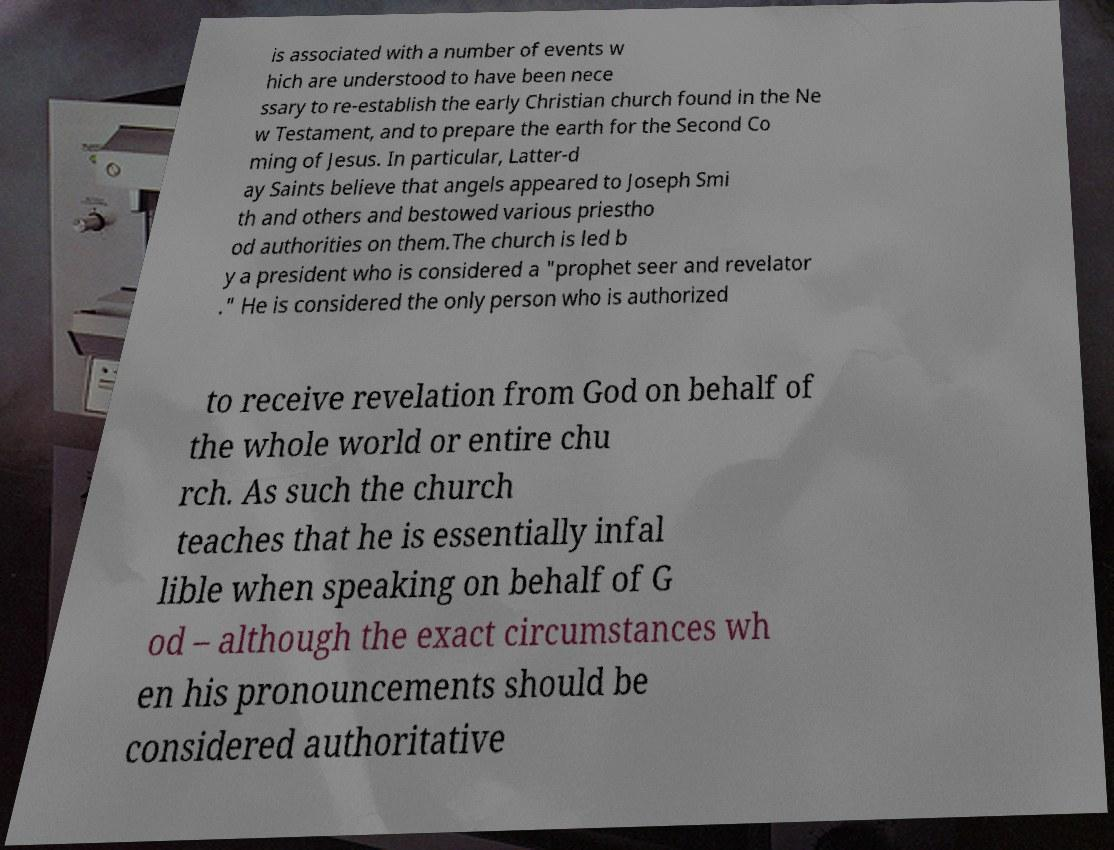For documentation purposes, I need the text within this image transcribed. Could you provide that? is associated with a number of events w hich are understood to have been nece ssary to re-establish the early Christian church found in the Ne w Testament, and to prepare the earth for the Second Co ming of Jesus. In particular, Latter-d ay Saints believe that angels appeared to Joseph Smi th and others and bestowed various priestho od authorities on them.The church is led b y a president who is considered a "prophet seer and revelator ." He is considered the only person who is authorized to receive revelation from God on behalf of the whole world or entire chu rch. As such the church teaches that he is essentially infal lible when speaking on behalf of G od – although the exact circumstances wh en his pronouncements should be considered authoritative 